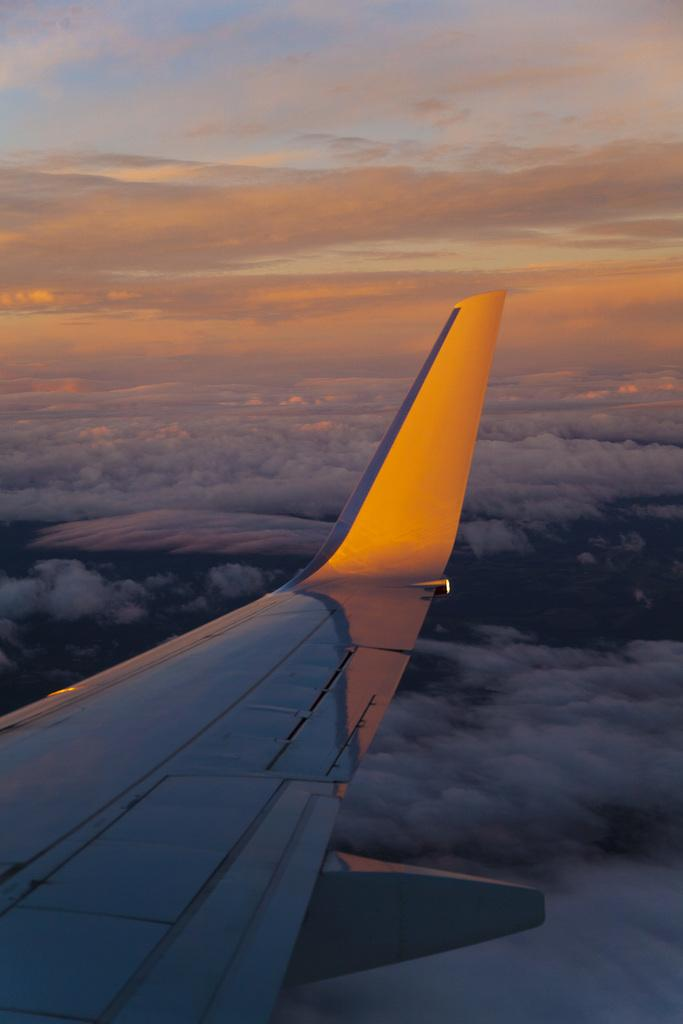What is the main subject of the image? The main subject of the image is a part of a flight. What can be seen in the background of the image? There is sky visible in the image. What is present in the sky in the image? There are clouds in the sky in the image. What type of answer can be seen coming from the flight attendant in the image? There is no flight attendant present in the image, so it's not possible to determine what, if any, answer might be seen. 